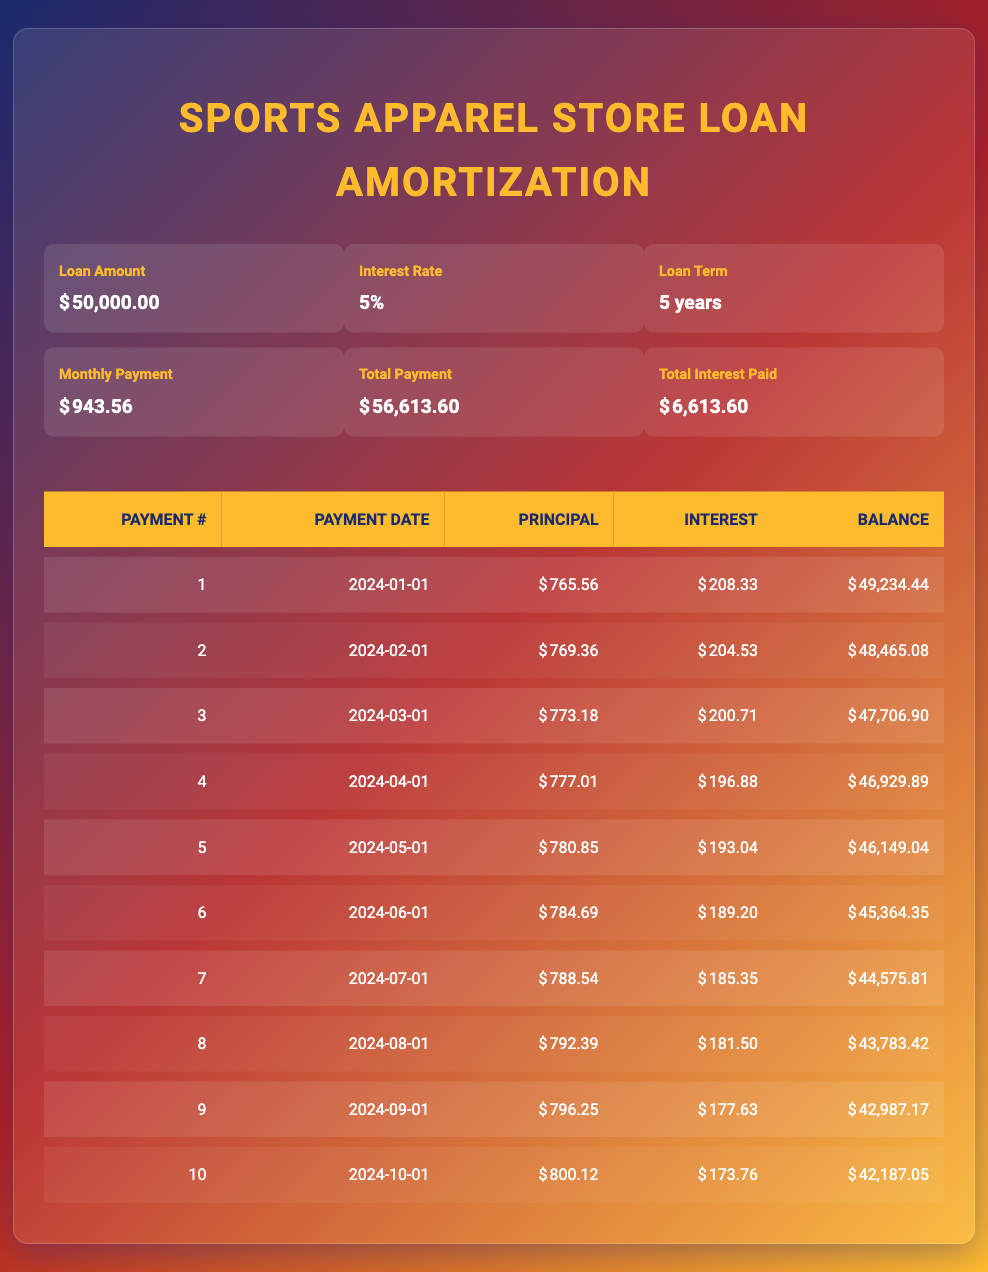What is the total interest paid over the loan term? The total interest paid is directly given in the loan details section of the table, which states it is 6,613.60.
Answer: 6,613.60 What is the monthly payment amount? The monthly payment amount is also provided in the loan details section of the table, listed as 943.56.
Answer: 943.56 How much principal was paid in the first payment? Referring to the amortization schedule, the principal payment for the first payment number is 765.56.
Answer: 765.56 What is the remaining balance after the second payment? From the amortization schedule, after the second payment, the remaining balance is listed as 48,465.08.
Answer: 48,465.08 Is the monthly payment higher than the interest payment for the first payment? According to the amortization schedule, the interest payment for the first payment is 208.33 and the total monthly payment is 943.56, which is higher.
Answer: Yes What is the average principal payment for the first five months? To find the average, add the principal payments for the first five months: 765.56 + 769.36 + 773.18 + 777.01 + 780.85 = 3,865.96. Then divide by 5, which results in 773.19.
Answer: 773.19 How much did the interest payment decrease from the first to the fifth payment? The interest payment for the first payment is 208.33, and for the fifth payment, it is 193.04. The decrease is 208.33 - 193.04 = 15.29.
Answer: 15.29 Which month shows the highest principal payment, and what is that amount? Reviewing the amortization schedule, the highest principal payment occurs in the seventh payment with an amount of 788.54.
Answer: 788.54 What will be the remaining balance after the tenth payment? The remaining balance after the tenth payment is provided in the schedule as 42,187.05.
Answer: 42,187.05 What is the total amount paid towards the loan after 10 payments? The total payment after 10 months is calculated as 943.56 multiplied by 10, which equals 9,435.60.
Answer: 9,435.60 